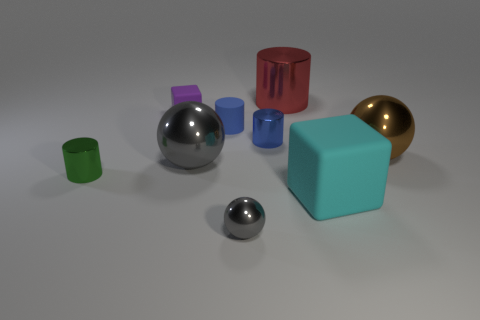Subtract 1 cylinders. How many cylinders are left? 3 Add 1 cyan rubber balls. How many objects exist? 10 Subtract all cylinders. How many objects are left? 5 Subtract all rubber cubes. Subtract all brown objects. How many objects are left? 6 Add 4 big red shiny cylinders. How many big red shiny cylinders are left? 5 Add 1 big green matte things. How many big green matte things exist? 1 Subtract 1 gray spheres. How many objects are left? 8 